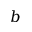<formula> <loc_0><loc_0><loc_500><loc_500>b</formula> 